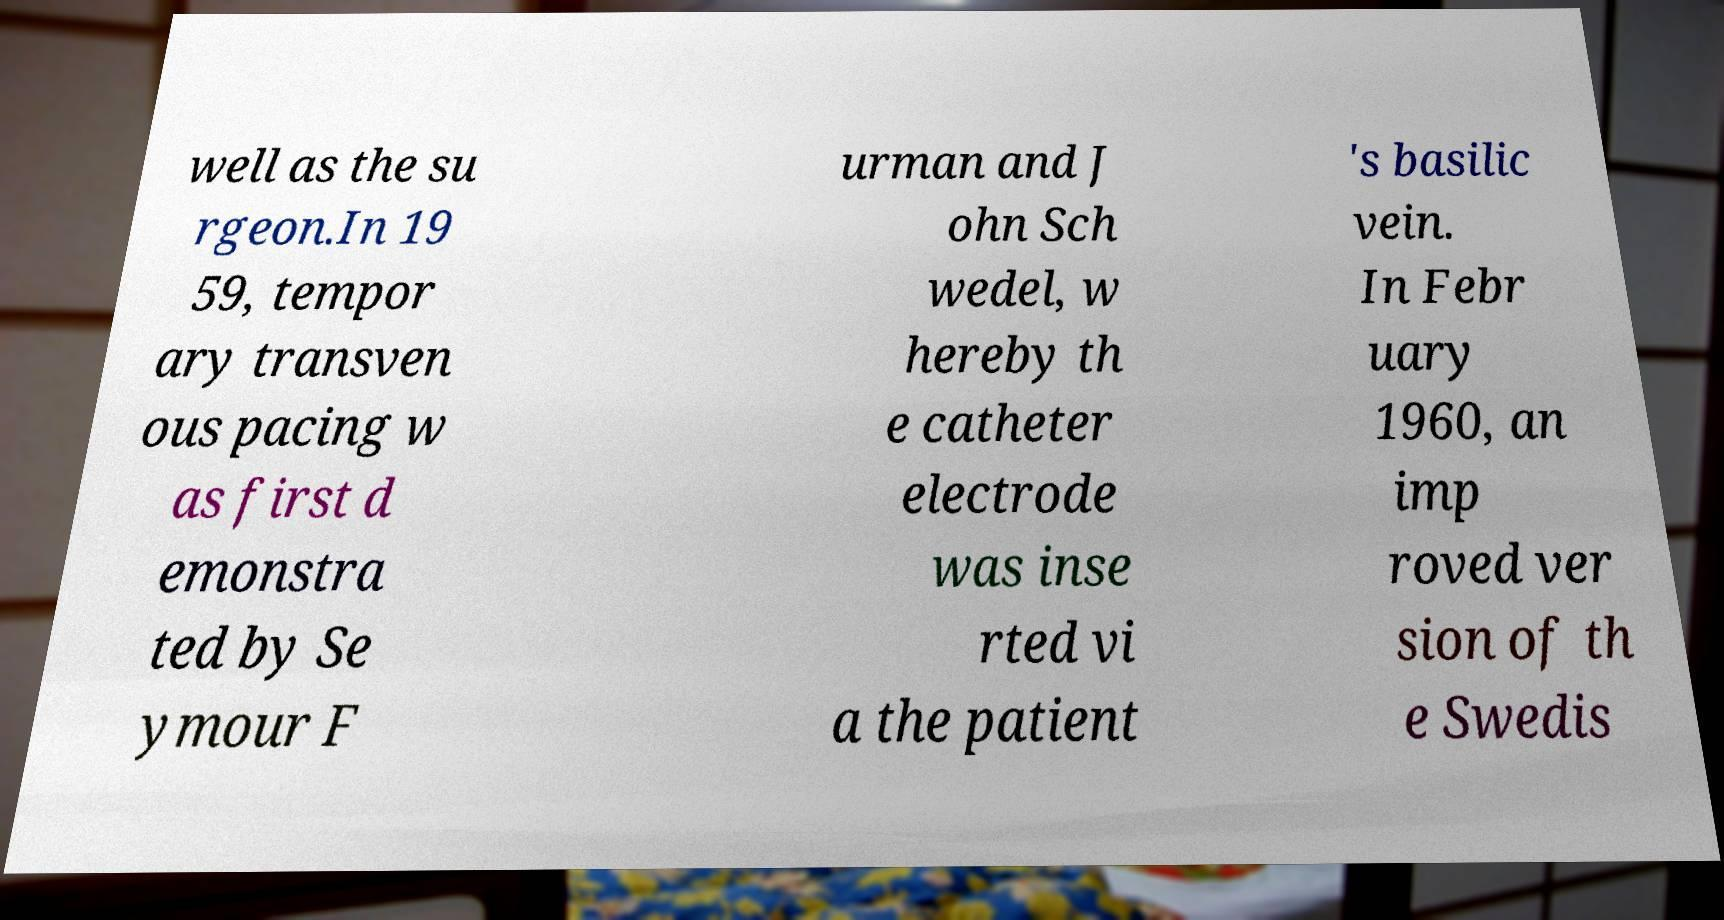Please read and relay the text visible in this image. What does it say? well as the su rgeon.In 19 59, tempor ary transven ous pacing w as first d emonstra ted by Se ymour F urman and J ohn Sch wedel, w hereby th e catheter electrode was inse rted vi a the patient 's basilic vein. In Febr uary 1960, an imp roved ver sion of th e Swedis 